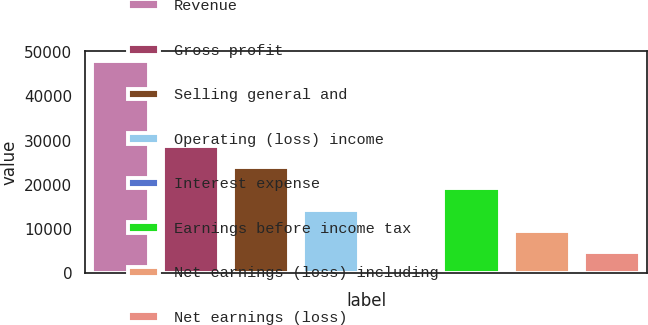Convert chart. <chart><loc_0><loc_0><loc_500><loc_500><bar_chart><fcel>Revenue<fcel>Gross profit<fcel>Selling general and<fcel>Operating (loss) income<fcel>Interest expense<fcel>Earnings before income tax<fcel>Net earnings (loss) including<fcel>Net earnings (loss)<nl><fcel>47925<fcel>28762.6<fcel>23972<fcel>14390.8<fcel>19<fcel>19181.4<fcel>9600.2<fcel>4809.6<nl></chart> 